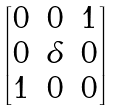Convert formula to latex. <formula><loc_0><loc_0><loc_500><loc_500>\begin{bmatrix} 0 & 0 & 1 \\ 0 & \delta & 0 \\ 1 & 0 & 0 \end{bmatrix}</formula> 